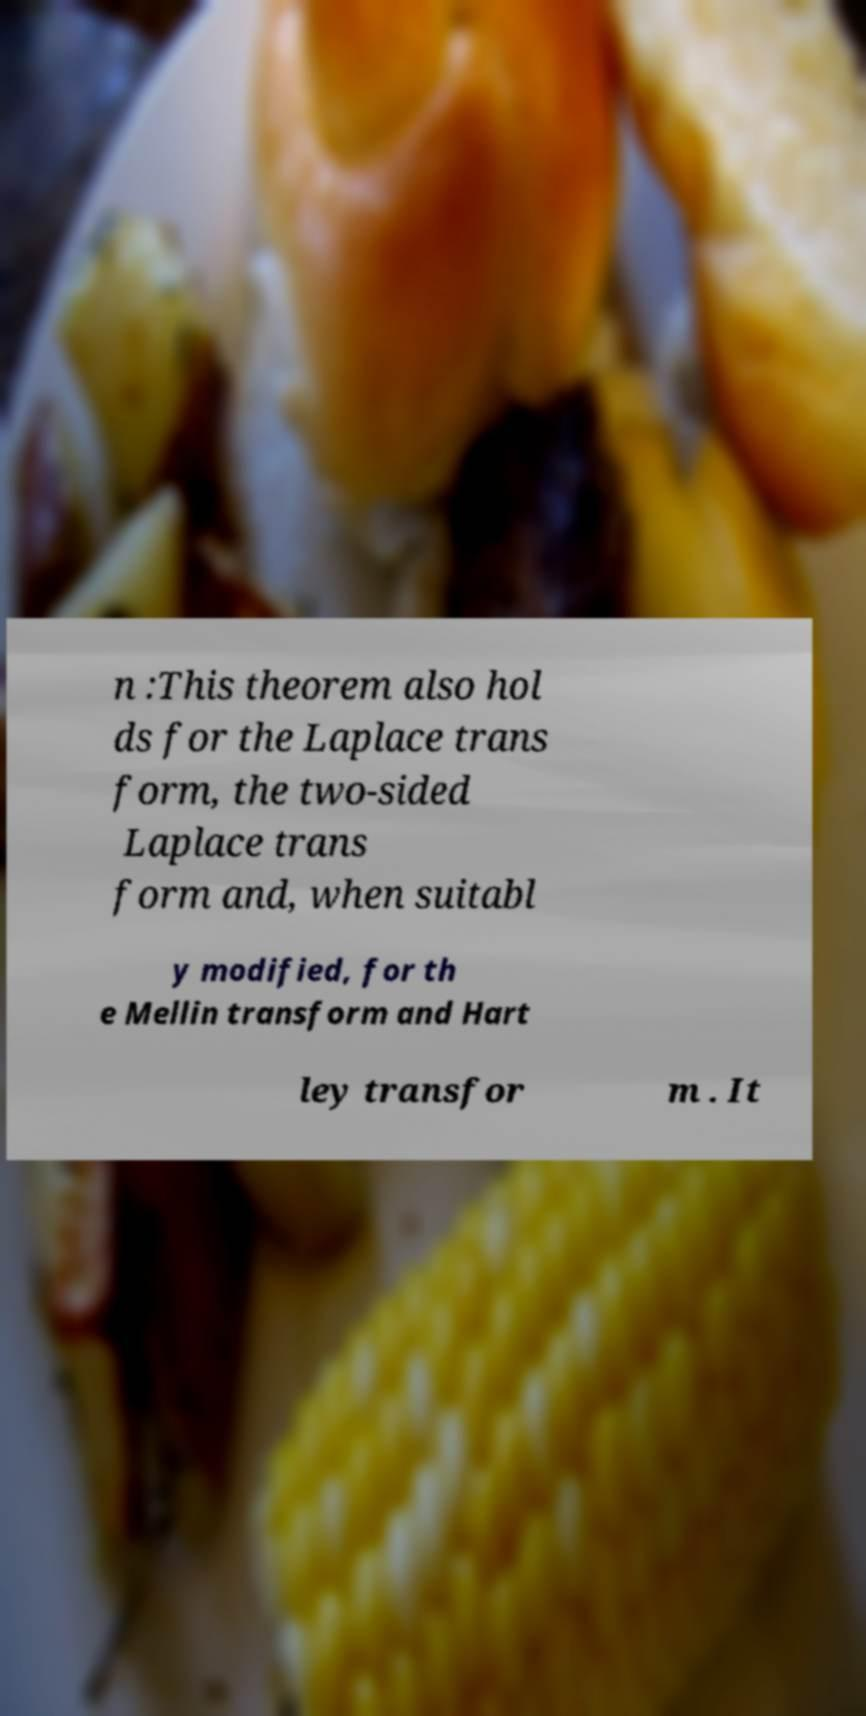Can you accurately transcribe the text from the provided image for me? n :This theorem also hol ds for the Laplace trans form, the two-sided Laplace trans form and, when suitabl y modified, for th e Mellin transform and Hart ley transfor m . It 